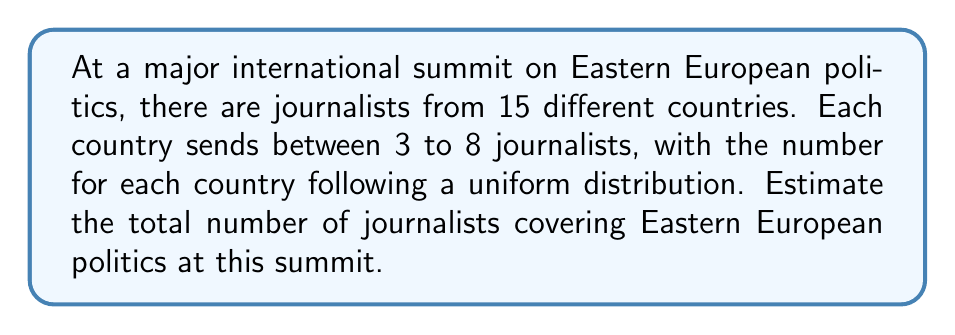Provide a solution to this math problem. To estimate the total number of journalists, we need to:

1. Identify the probability distribution: Uniform distribution between 3 and 8 journalists per country.

2. Calculate the expected value (mean) for each country:
   The expected value for a uniform distribution is the average of its minimum and maximum values.
   $$E(X) = \frac{a + b}{2}$$
   where $a$ is the minimum and $b$ is the maximum.
   
   $$E(X) = \frac{3 + 8}{2} = \frac{11}{2} = 5.5$$

3. Multiply the expected value by the number of countries:
   Total estimated journalists = Expected journalists per country × Number of countries
   $$\text{Total} = 5.5 \times 15 = 82.5$$

4. Round to the nearest whole number, as we can't have fractional journalists:
   $$\text{Rounded total} = 83$$

Therefore, we estimate that there will be approximately 83 journalists covering Eastern European politics at this major international summit.
Answer: 83 journalists 